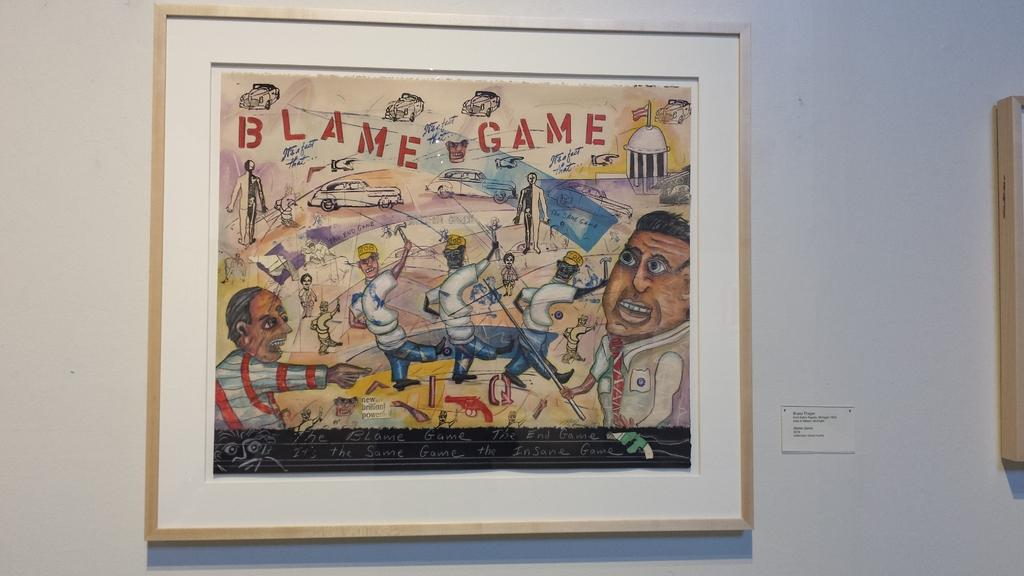<image>
Write a terse but informative summary of the picture. a framed colored cartoon drawing of blame game 